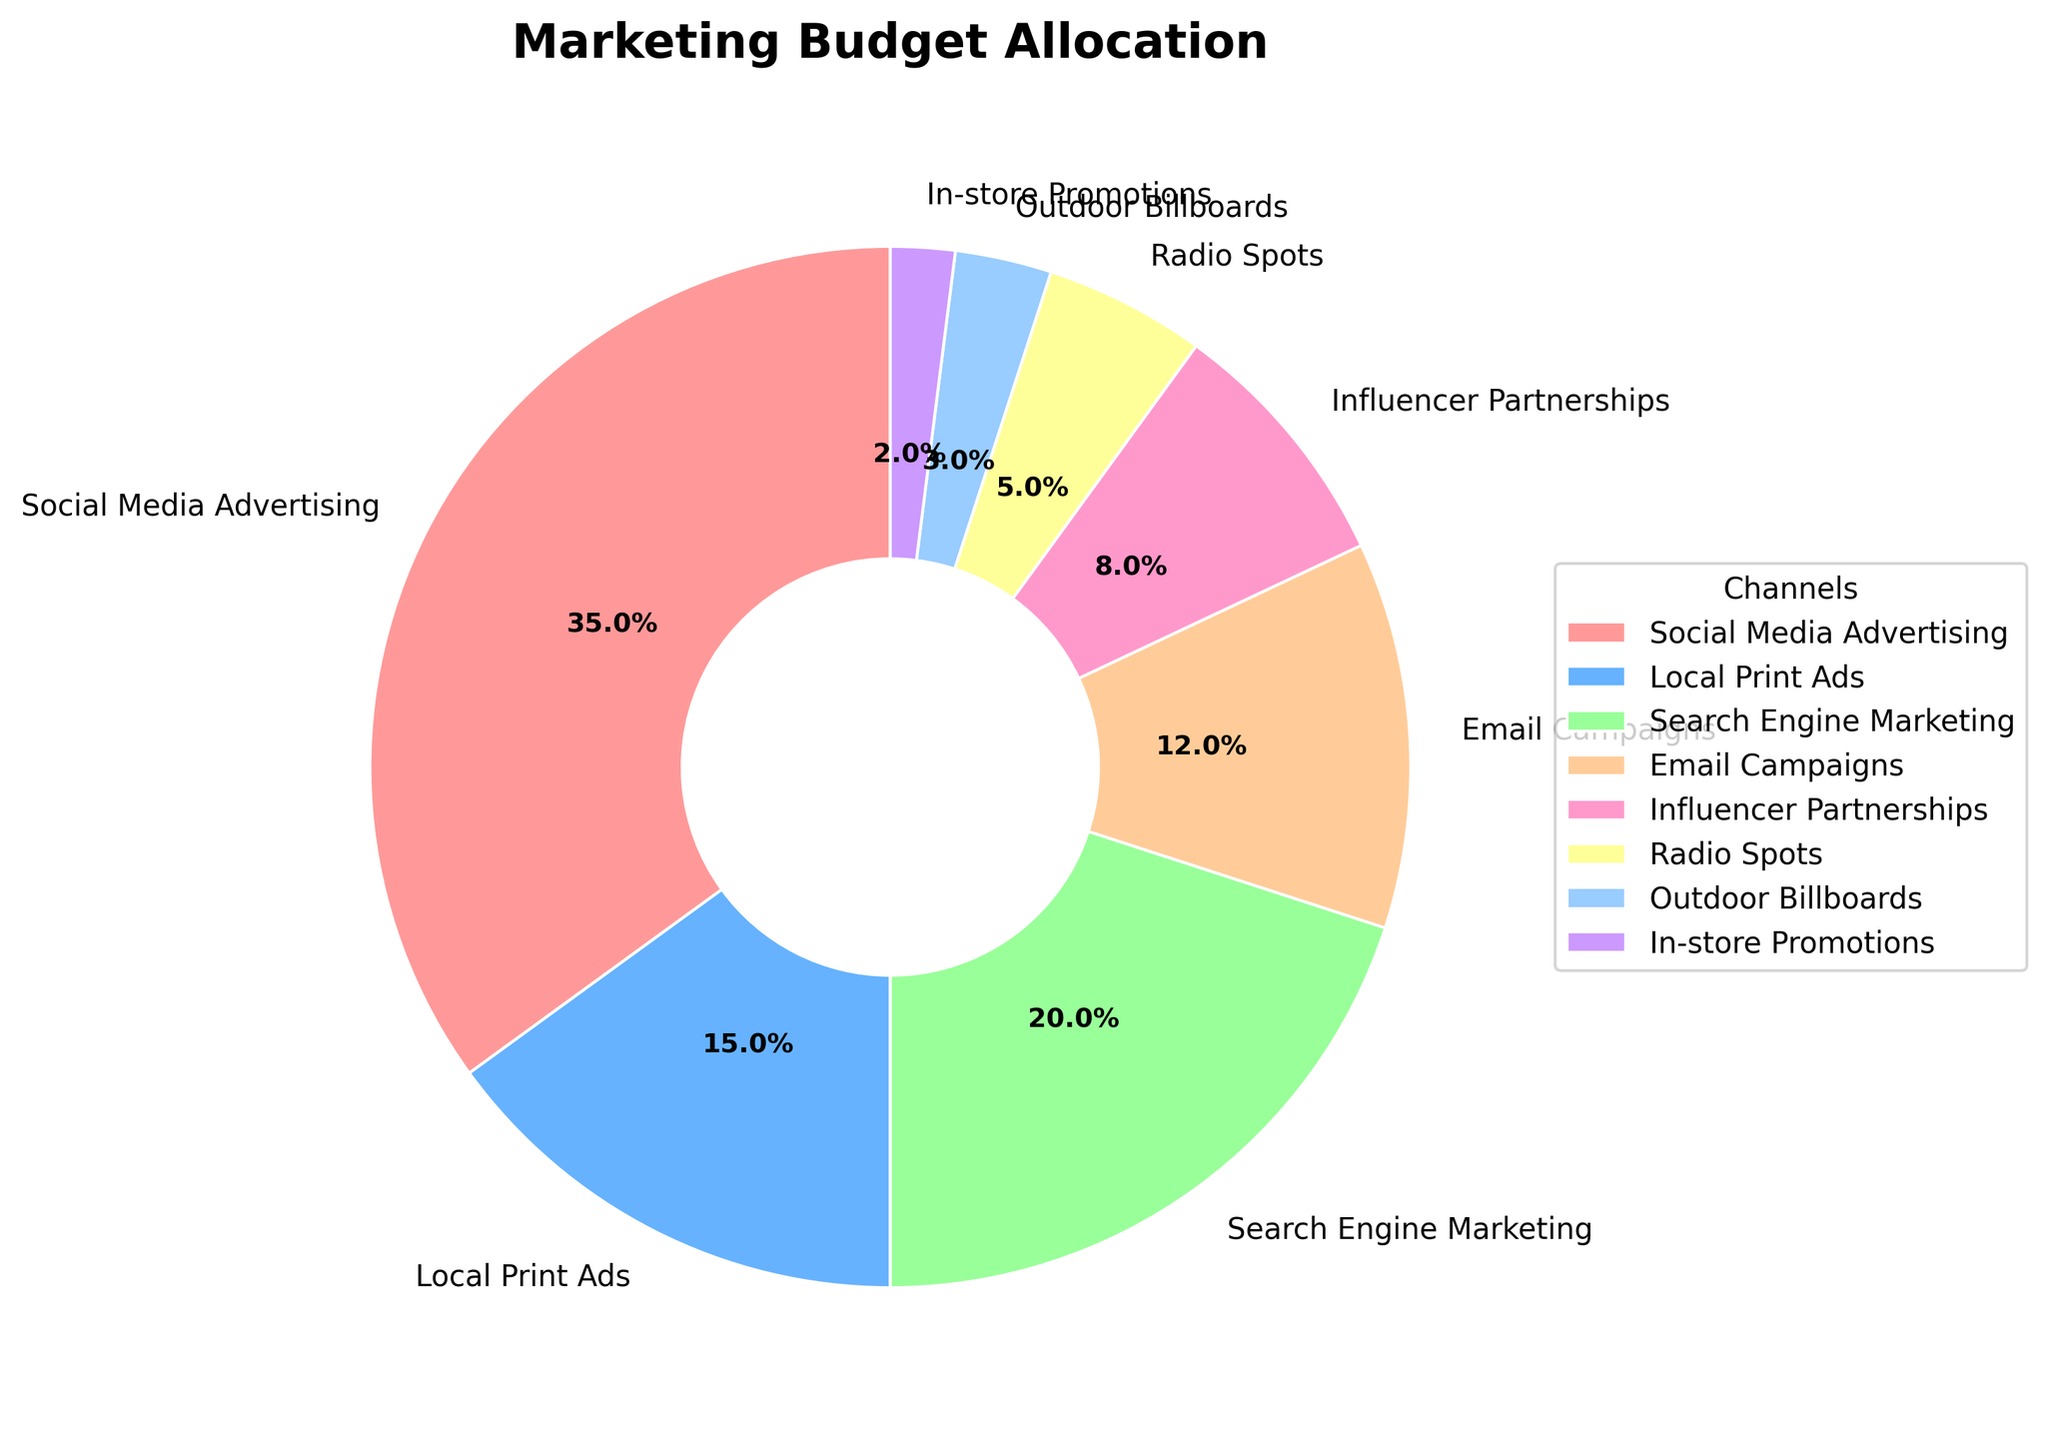Which channel receives the highest percentage of the marketing budget? Look at the segment with the largest size in the pie chart. The label for that segment indicates the channel and its percentage.
Answer: Social Media Advertising How much more budget is allocated to Social Media Advertising compared to Radio Spots? Identify the percentages for Social Media Advertising (35%) and Radio Spots (5%) from the chart. Calculate the difference: 35% - 5% = 30%.
Answer: 30% Which channels together make up 50% of the marketing budget? Identify the channels with the largest percentages from the pie chart. Adding Social Media Advertising (35%) and Search Engine Marketing (20%) gives 55%, which is over 50%. Therefore, add Social Media Advertising (35%) and Local Print Ads (15%) to get exactly 50%.
Answer: Social Media Advertising and Local Print Ads Are there more funds allocated to Email Campaigns or Outdoor Billboards? Compare the sizes of the segments labeled Email Campaigns (12%) and Outdoor Billboards (3%).
Answer: Email Campaigns What's the total percentage of the marketing budget allocated to Email Campaigns, Radio Spots, and In-store Promotions combined? Identify the percentages from the chart: Email Campaigns (12%), Radio Spots (5%), In-store Promotions (2%). Sum them up: 12% + 5% + 2% = 19%.
Answer: 19% Do any two channels have an equal percentage allocation? Check the chart to see if any segments have the same percentage value. In this case, no segments have equal percentages.
Answer: No What is the difference in budget allocation between the channel with the lowest percentage and the channel with the highest percentage? Identify the highest percentage (Social Media Advertising, 35%) and the lowest percentage (In-store Promotions, 2%). Find the difference: 35% - 2% = 33%.
Answer: 33% Which channel represents the smallest portion of the marketing budget? Find the segment with the smallest size and check its label.
Answer: In-store Promotions 